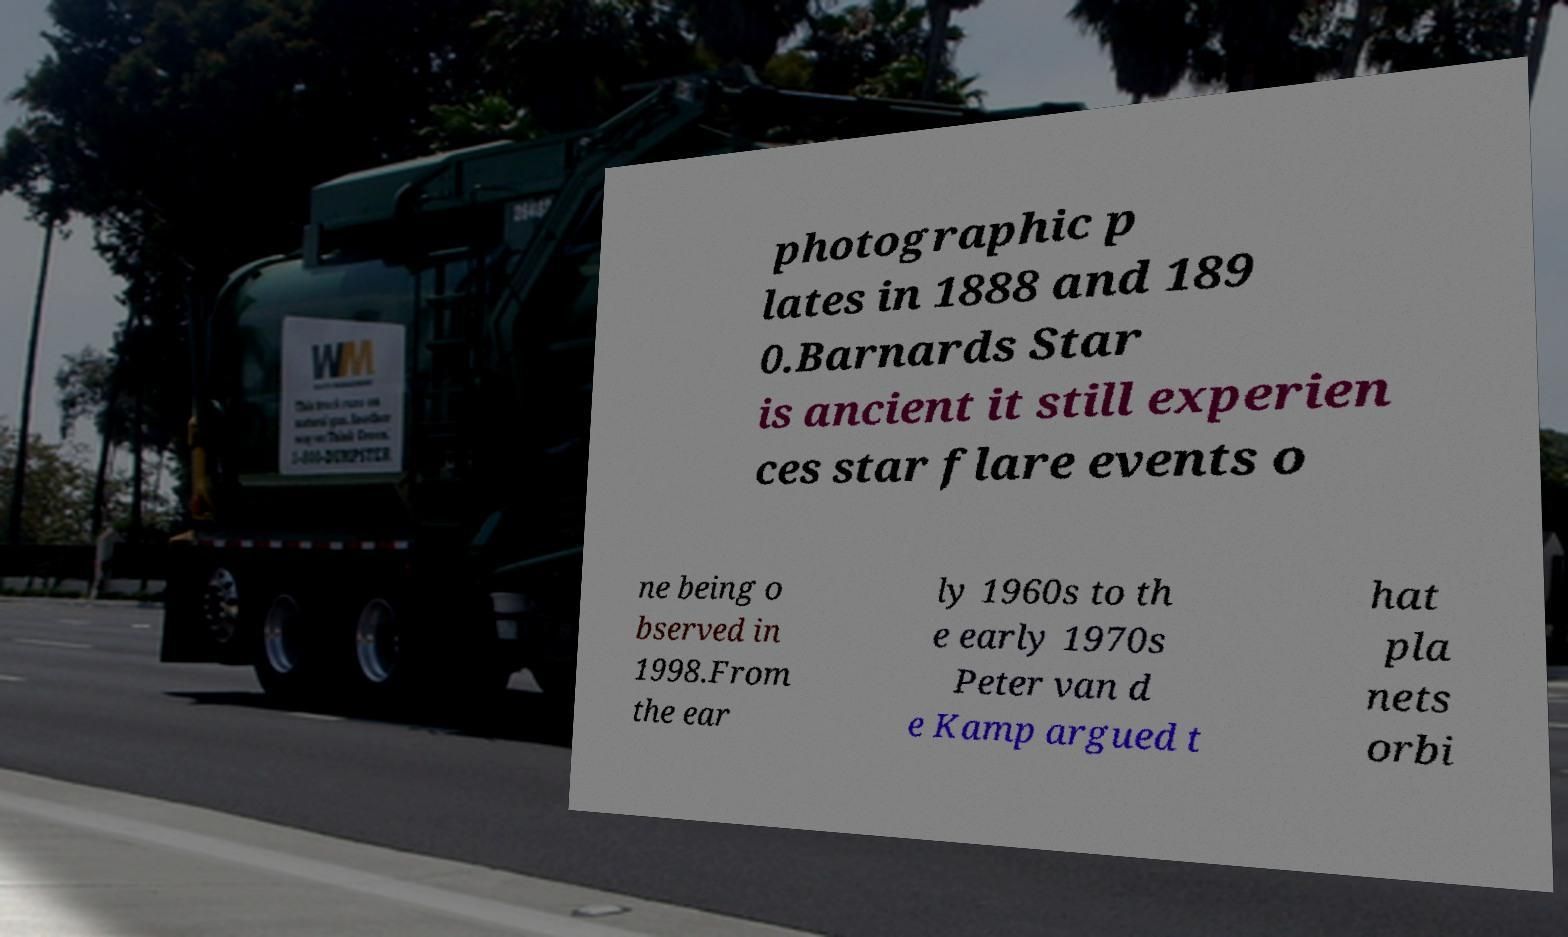Could you extract and type out the text from this image? photographic p lates in 1888 and 189 0.Barnards Star is ancient it still experien ces star flare events o ne being o bserved in 1998.From the ear ly 1960s to th e early 1970s Peter van d e Kamp argued t hat pla nets orbi 